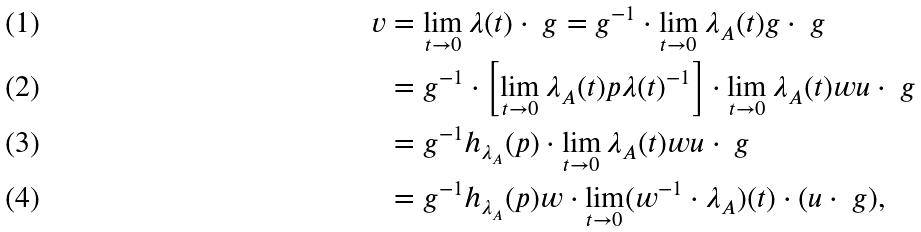Convert formula to latex. <formula><loc_0><loc_0><loc_500><loc_500>v & = \lim _ { t \to 0 } \lambda ( t ) \cdot \ g = g ^ { - 1 } \cdot \lim _ { t \to 0 } \lambda _ { A } ( t ) g \cdot \ g \\ & = g ^ { - 1 } \cdot \left [ \lim _ { t \to 0 } \lambda _ { A } ( t ) p \lambda ( t ) ^ { - 1 } \right ] \cdot \lim _ { t \to 0 } \lambda _ { A } ( t ) w u \cdot \ g \\ & = g ^ { - 1 } h _ { \lambda _ { A } } ( p ) \cdot \lim _ { t \to 0 } \lambda _ { A } ( t ) w u \cdot \ g \\ & = g ^ { - 1 } h _ { \lambda _ { A } } ( p ) w \cdot \lim _ { t \to 0 } ( w ^ { - 1 } \cdot \lambda _ { A } ) ( t ) \cdot ( u \cdot \ g ) ,</formula> 